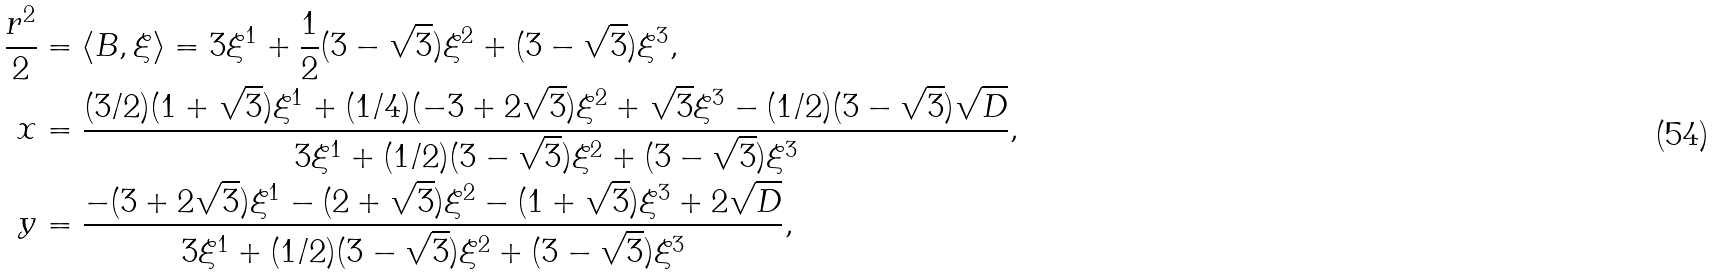Convert formula to latex. <formula><loc_0><loc_0><loc_500><loc_500>\frac { r ^ { 2 } } { 2 } & = \langle B , \xi \rangle = 3 \xi ^ { 1 } + \frac { 1 } { 2 } ( 3 - \sqrt { 3 } ) \xi ^ { 2 } + ( 3 - \sqrt { 3 } ) \xi ^ { 3 } , \\ x & = \frac { ( 3 / 2 ) ( 1 + \sqrt { 3 } ) \xi ^ { 1 } + ( 1 / 4 ) ( - 3 + 2 \sqrt { 3 } ) \xi ^ { 2 } + \sqrt { 3 } \xi ^ { 3 } - ( 1 / 2 ) ( 3 - \sqrt { 3 } ) \sqrt { D } } { 3 \xi ^ { 1 } + ( 1 / 2 ) ( 3 - \sqrt { 3 } ) \xi ^ { 2 } + ( 3 - \sqrt { 3 } ) \xi ^ { 3 } } , \\ y & = \frac { - ( 3 + 2 \sqrt { 3 } ) \xi ^ { 1 } - ( 2 + \sqrt { 3 } ) \xi ^ { 2 } - ( 1 + \sqrt { 3 } ) \xi ^ { 3 } + 2 \sqrt { D } } { 3 \xi ^ { 1 } + ( 1 / 2 ) ( 3 - \sqrt { 3 } ) \xi ^ { 2 } + ( 3 - \sqrt { 3 } ) \xi ^ { 3 } } ,</formula> 